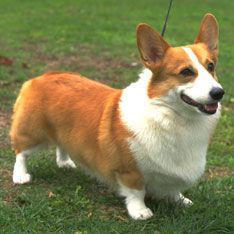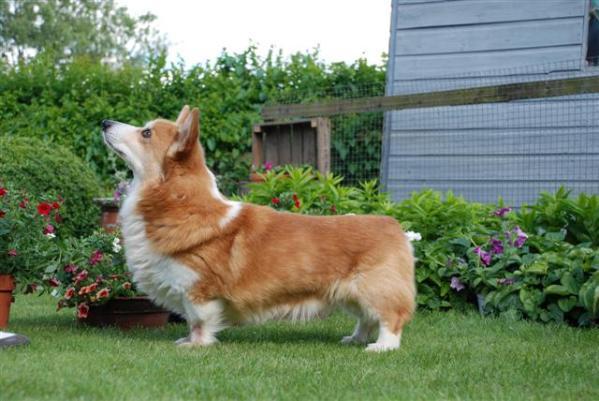The first image is the image on the left, the second image is the image on the right. For the images displayed, is the sentence "All short-legged dogs are standing alert on some grass." factually correct? Answer yes or no. Yes. The first image is the image on the left, the second image is the image on the right. Given the left and right images, does the statement "A dog is facing to the left with his head raised up in a picture." hold true? Answer yes or no. Yes. 